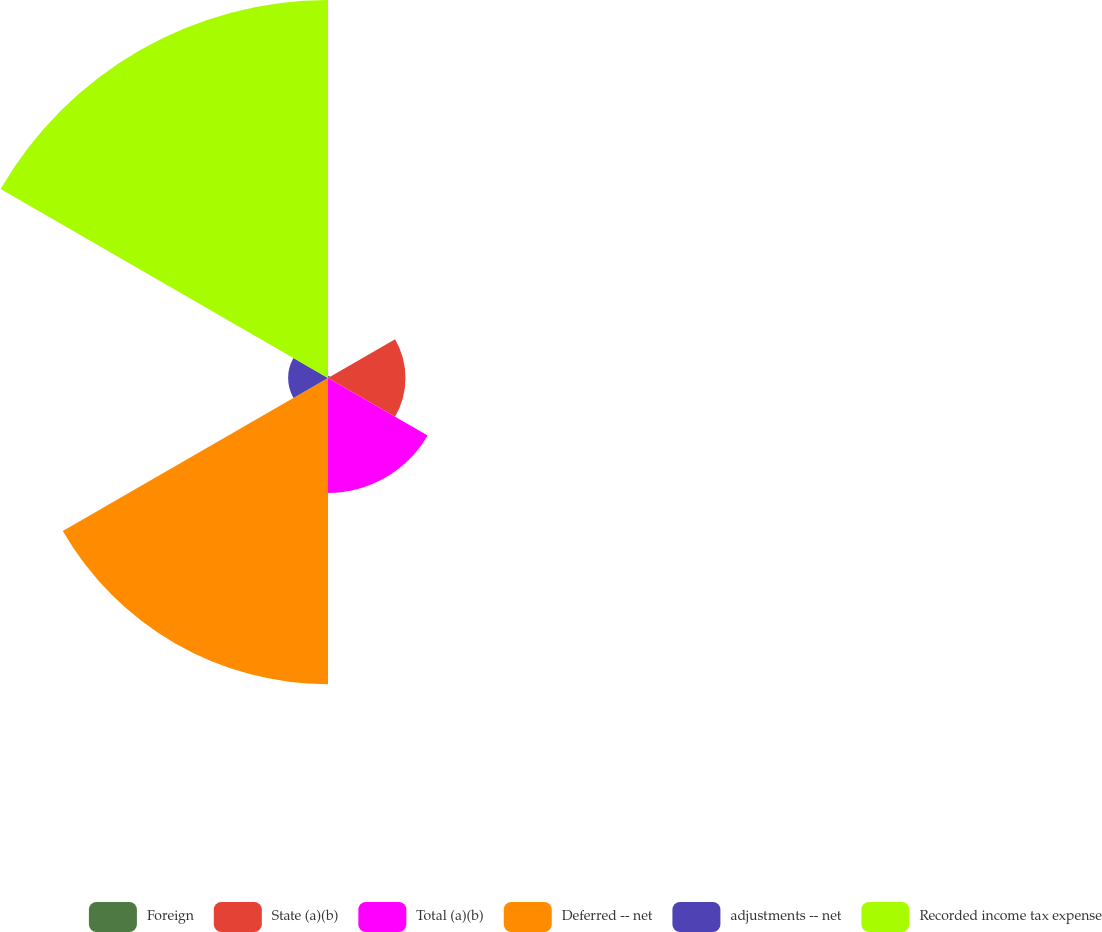<chart> <loc_0><loc_0><loc_500><loc_500><pie_chart><fcel>Foreign<fcel>State (a)(b)<fcel>Total (a)(b)<fcel>Deferred -- net<fcel>adjustments -- net<fcel>Recorded income tax expense<nl><fcel>0.25%<fcel>8.43%<fcel>12.52%<fcel>33.33%<fcel>4.34%<fcel>41.14%<nl></chart> 